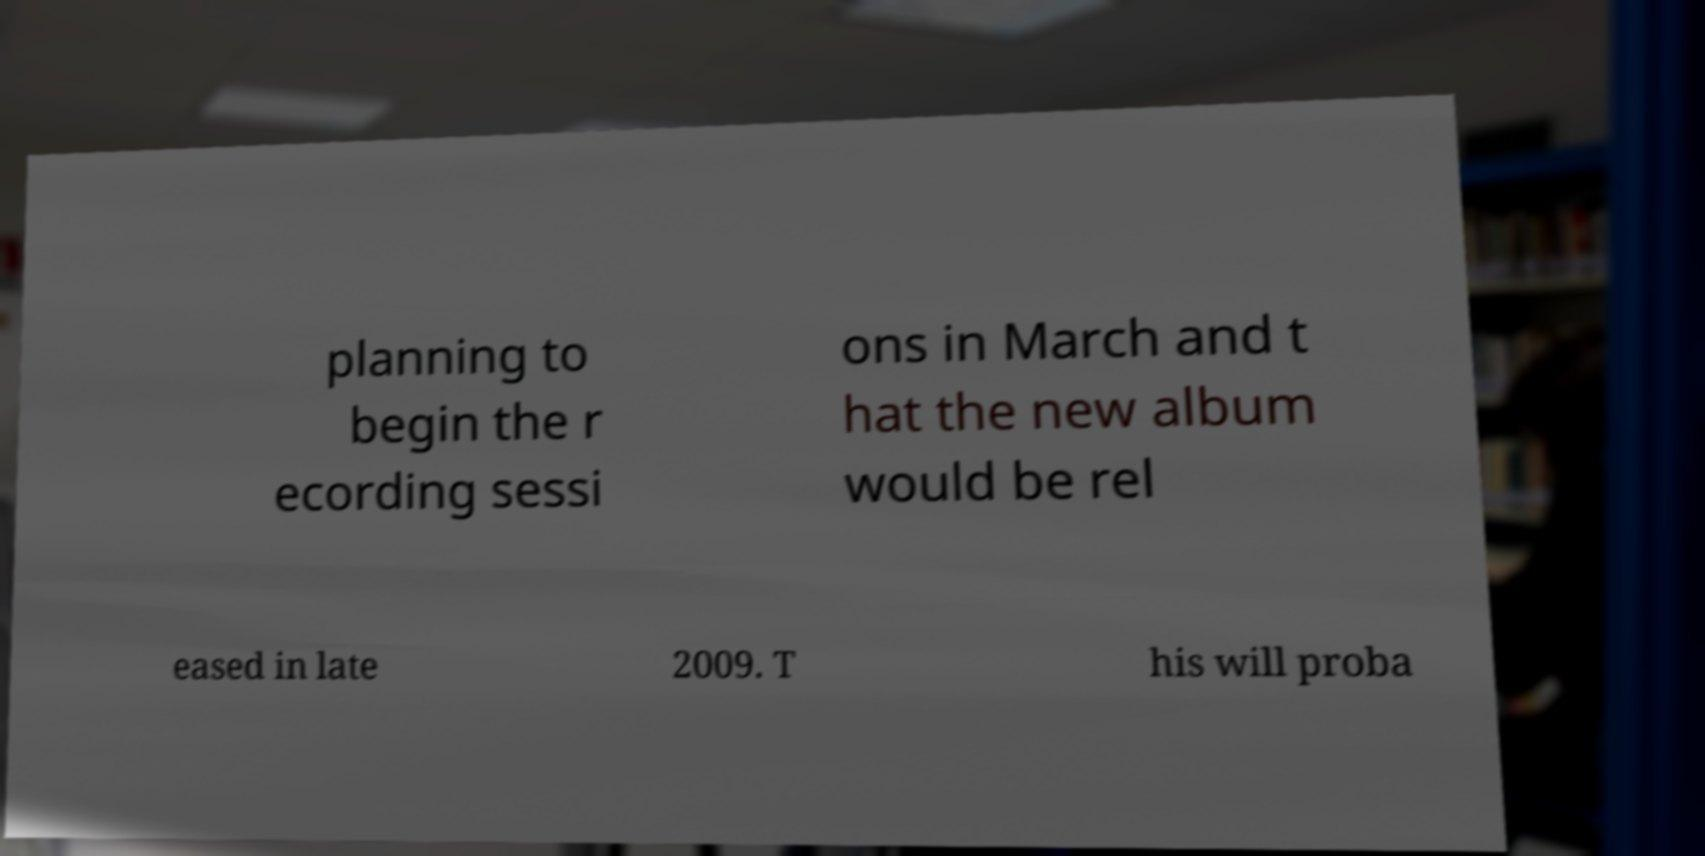For documentation purposes, I need the text within this image transcribed. Could you provide that? planning to begin the r ecording sessi ons in March and t hat the new album would be rel eased in late 2009. T his will proba 